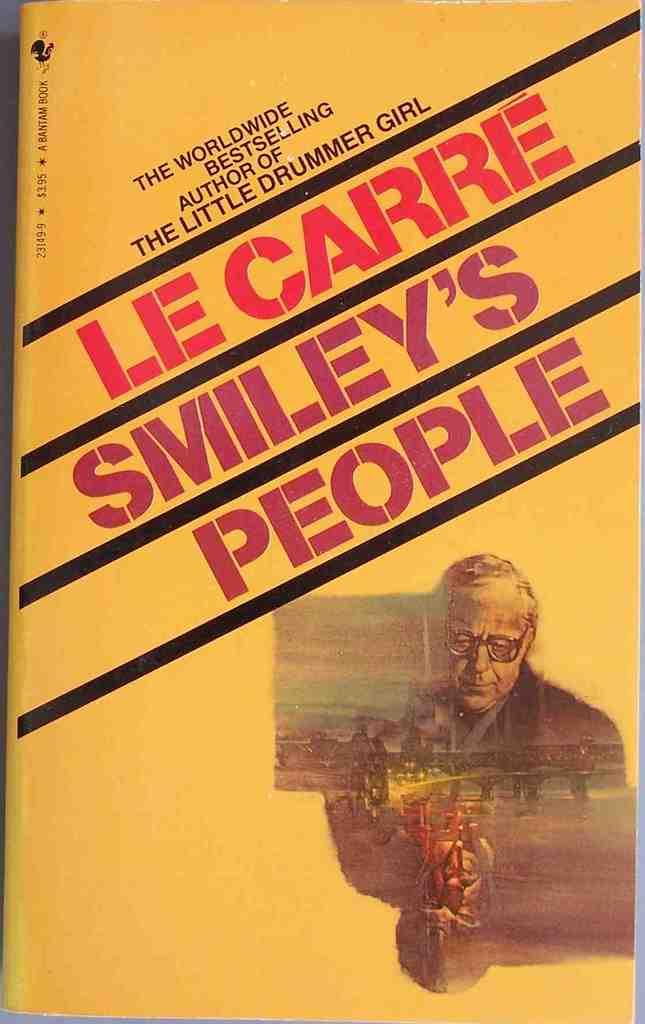What is the saying in purple?
Keep it short and to the point. Smiley's people. What is the bottom slanted word?
Make the answer very short. People. 